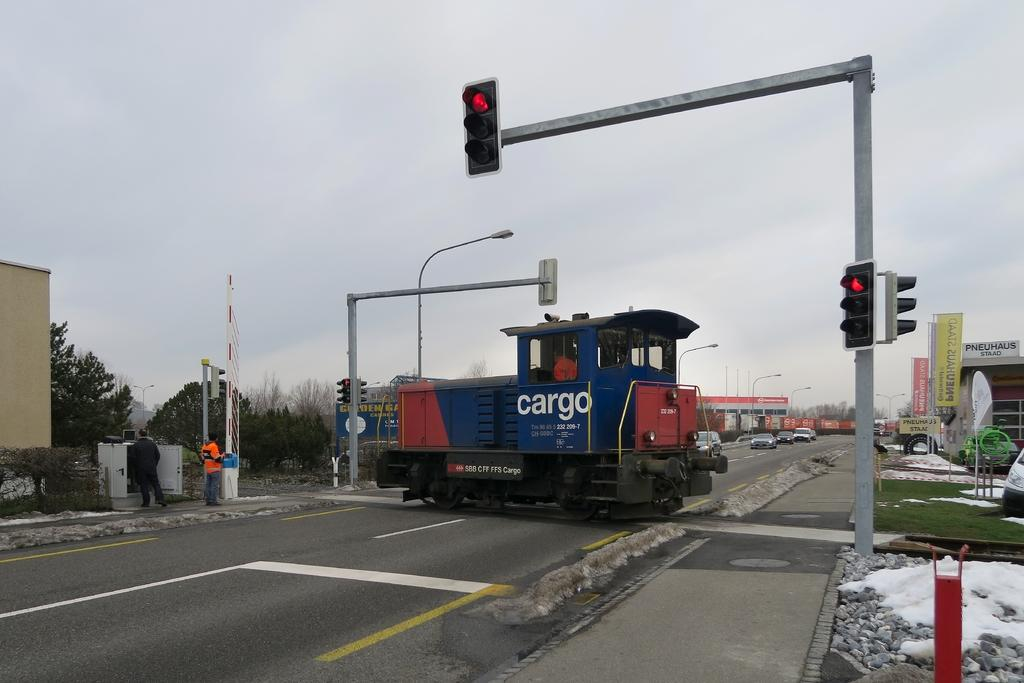<image>
Share a concise interpretation of the image provided. Blue vehicle that says cargo in the middle of a street. 